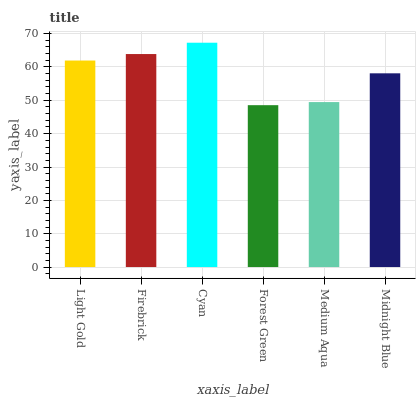Is Forest Green the minimum?
Answer yes or no. Yes. Is Cyan the maximum?
Answer yes or no. Yes. Is Firebrick the minimum?
Answer yes or no. No. Is Firebrick the maximum?
Answer yes or no. No. Is Firebrick greater than Light Gold?
Answer yes or no. Yes. Is Light Gold less than Firebrick?
Answer yes or no. Yes. Is Light Gold greater than Firebrick?
Answer yes or no. No. Is Firebrick less than Light Gold?
Answer yes or no. No. Is Light Gold the high median?
Answer yes or no. Yes. Is Midnight Blue the low median?
Answer yes or no. Yes. Is Cyan the high median?
Answer yes or no. No. Is Light Gold the low median?
Answer yes or no. No. 